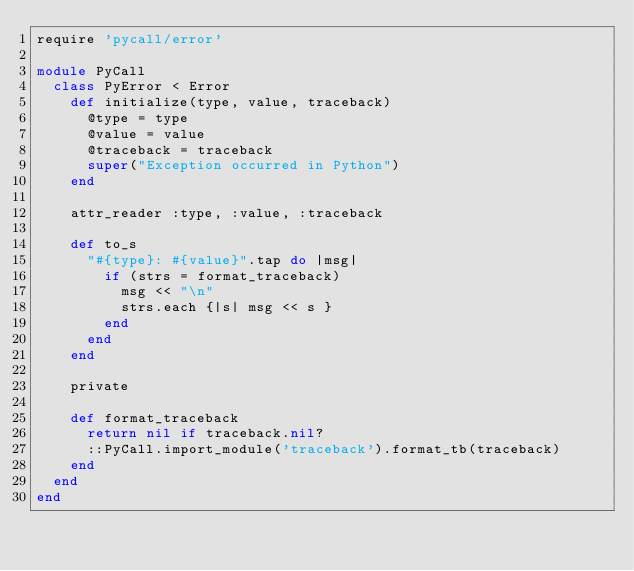Convert code to text. <code><loc_0><loc_0><loc_500><loc_500><_Ruby_>require 'pycall/error'

module PyCall
  class PyError < Error
    def initialize(type, value, traceback)
      @type = type
      @value = value
      @traceback = traceback
      super("Exception occurred in Python")
    end

    attr_reader :type, :value, :traceback

    def to_s
      "#{type}: #{value}".tap do |msg|
        if (strs = format_traceback)
          msg << "\n"
          strs.each {|s| msg << s }
        end
      end
    end

    private

    def format_traceback
      return nil if traceback.nil?
      ::PyCall.import_module('traceback').format_tb(traceback)
    end
  end
end
</code> 